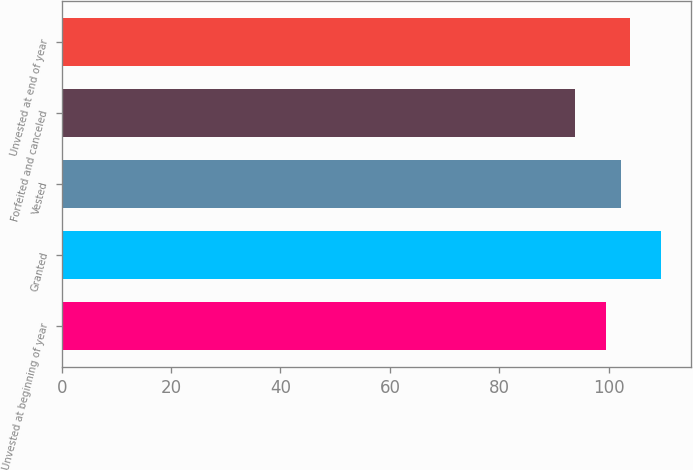<chart> <loc_0><loc_0><loc_500><loc_500><bar_chart><fcel>Unvested at beginning of year<fcel>Granted<fcel>Vested<fcel>Forfeited and canceled<fcel>Unvested at end of year<nl><fcel>99.43<fcel>109.62<fcel>102.27<fcel>93.92<fcel>103.84<nl></chart> 